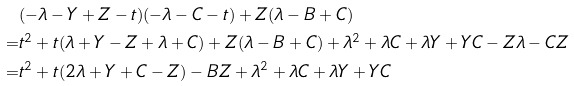Convert formula to latex. <formula><loc_0><loc_0><loc_500><loc_500>& ( - \lambda - Y + Z - t ) ( - \lambda - C - t ) + Z ( \lambda - B + C ) \\ = & t ^ { 2 } + t ( \lambda + Y - Z + \lambda + C ) + Z ( \lambda - B + C ) + \lambda ^ { 2 } + \lambda C + \lambda Y + Y C - Z \lambda - C Z \\ = & t ^ { 2 } + t ( 2 \lambda + Y + C - Z ) - B Z + \lambda ^ { 2 } + \lambda C + \lambda Y + Y C</formula> 